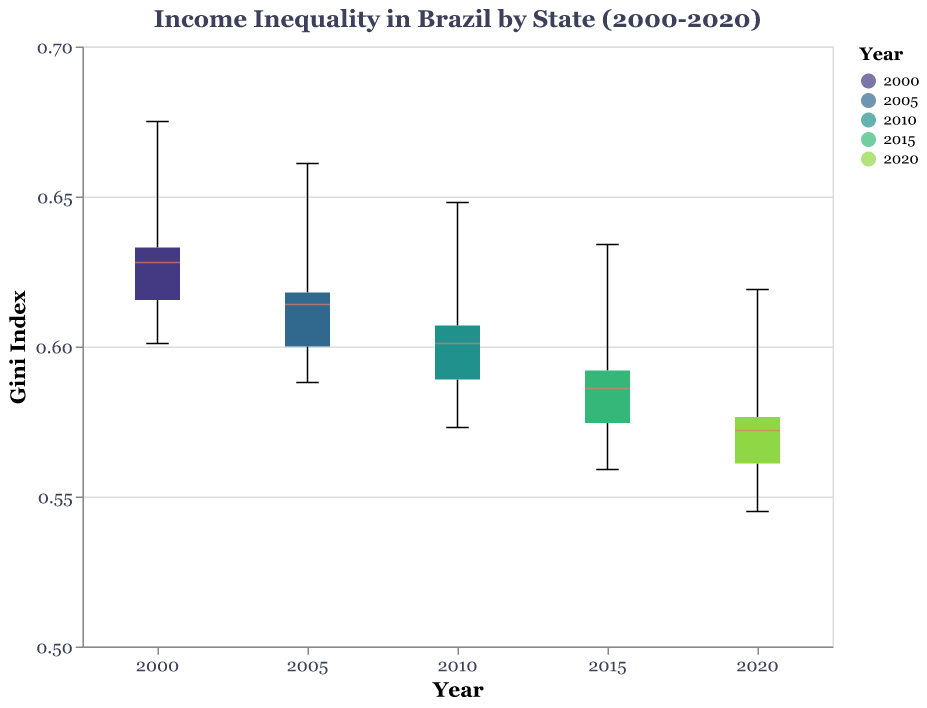What is the title of the figure? The title is displayed at the top of the figure and reads "Income Inequality in Brazil by State (2000-2020)".
Answer: Income Inequality in Brazil by State (2000-2020) What does the y-axis represent? The y-axis represents the "Gini Index", which measures income inequality.
Answer: Gini Index Which State has the highest Gini Index value in the year 2000? To find the highest Gini Index value for the year 2000, look at the box plots for 2000 and identify the state with the highest point. The Federal District has the highest Gini Index value of 0.675 in 2000.
Answer: Federal District Which year shows the lowest Gini Index for Alagoas? To find this, identify the box plot corresponding to Alagoas and check the minimum points for each year. The lowest Gini Index for Alagoas is in 2020, with a value of 0.575.
Answer: 2020 By how much did the Gini Index for Acre change from 2000 to 2020? Subtract the Gini Index value for Acre in 2020 from that in 2000: 0.609 (2000) - 0.554 (2020) = 0.055.
Answer: 0.055 Which year appears to have the least variation in Gini Index values across all states? Assess the notched box plots and identify the year with the smallest spread (narrowest boxes). The year 2020 appears to have the least variation.
Answer: 2020 What is the median Gini Index value for Ceará in 2010? Look at the notched box plot for Ceará in the year 2010 and identify the median line within the box. The median Gini Index for Ceará in 2010 is approximately 0.601.
Answer: 0.601 Compare the Gini Index for Bahia and Amazonas in 2020. Which is higher? Look at the 2020 data points for Bahia and Amazonas and compare their Gini Index values. Bahia has a Gini Index of 0.578 while Amazonas has a Gini Index of 0.568: 0.578 (Bahia) > 0.568 (Amazonas).
Answer: Bahia How has the Federal District's Gini Index changed from 2000 to 2020? Compare the Gini Index values for the Federal District in 2000 (0.675) and 2020 (0.619). The change is 0.675 - 0.619 = 0.056.
Answer: 0.056 Is there any state where the Gini Index consistently decreases from 2000 to 2020? Inspect the trends for each state across all years. Acre shows a consistent decrease from 0.609 in 2000 to 0.554 in 2020.
Answer: Acre 